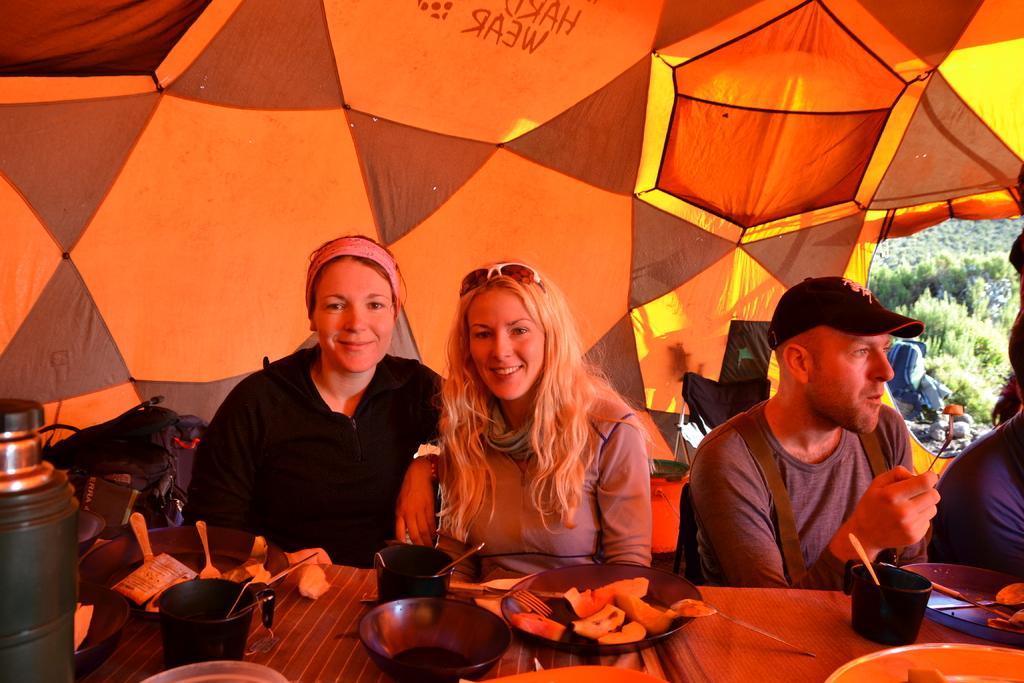Can you describe this image briefly? This picture describes about group of people, few are seated on the chairs and they are all in the tent, in front of them we can find few bowls, spoons, food, cups and other things on the tables, behind them we can find baggage, in the background we can see trees. 